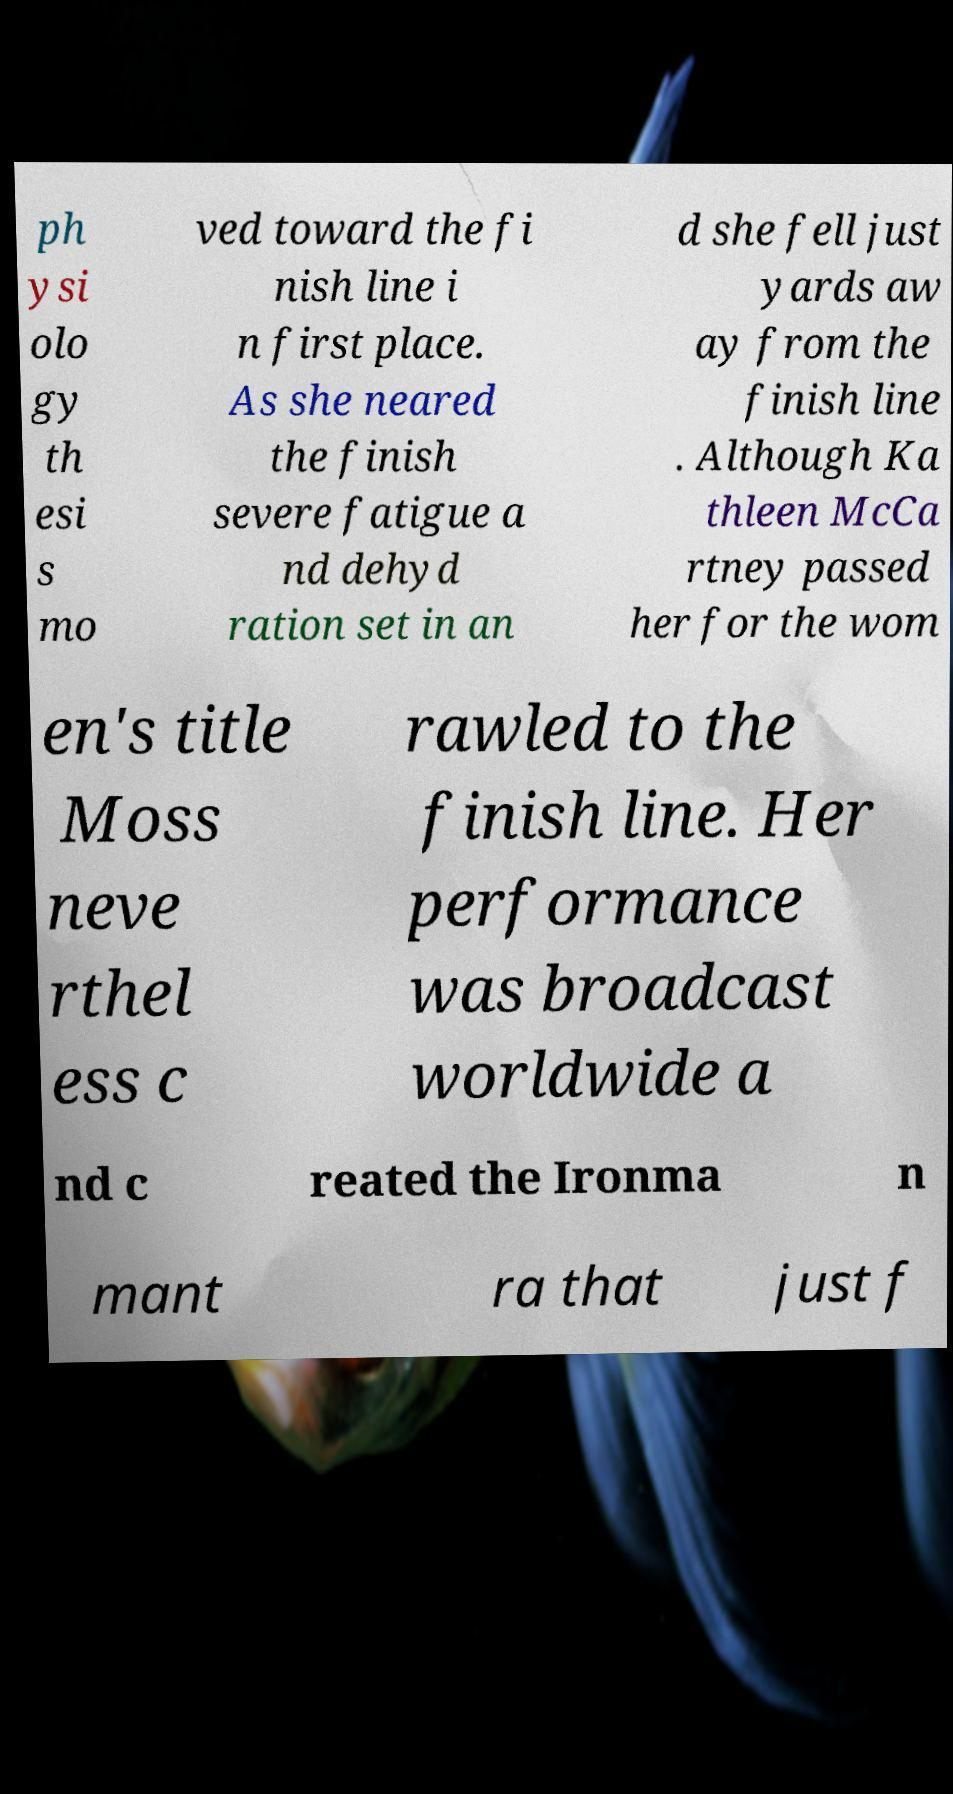I need the written content from this picture converted into text. Can you do that? ph ysi olo gy th esi s mo ved toward the fi nish line i n first place. As she neared the finish severe fatigue a nd dehyd ration set in an d she fell just yards aw ay from the finish line . Although Ka thleen McCa rtney passed her for the wom en's title Moss neve rthel ess c rawled to the finish line. Her performance was broadcast worldwide a nd c reated the Ironma n mant ra that just f 